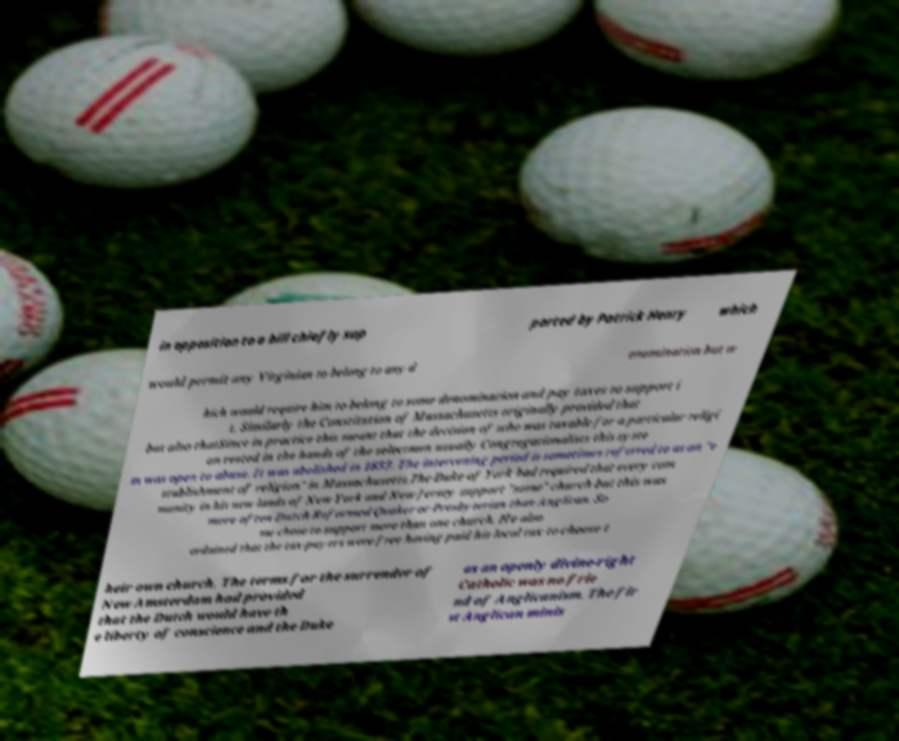Please read and relay the text visible in this image. What does it say? in opposition to a bill chiefly sup ported by Patrick Henry which would permit any Virginian to belong to any d enomination but w hich would require him to belong to some denomination and pay taxes to support i t. Similarly the Constitution of Massachusetts originally provided that but also thatSince in practice this meant that the decision of who was taxable for a particular religi on rested in the hands of the selectmen usually Congregationalists this syste m was open to abuse. It was abolished in 1833. The intervening period is sometimes referred to as an "e stablishment of religion" in Massachusetts.The Duke of York had required that every com munity in his new lands of New York and New Jersey support "some" church but this was more often Dutch Reformed Quaker or Presbyterian than Anglican. So me chose to support more than one church. He also ordained that the tax-payers were free having paid his local tax to choose t heir own church. The terms for the surrender of New Amsterdam had provided that the Dutch would have th e liberty of conscience and the Duke as an openly divine-right Catholic was no frie nd of Anglicanism. The fir st Anglican minis 